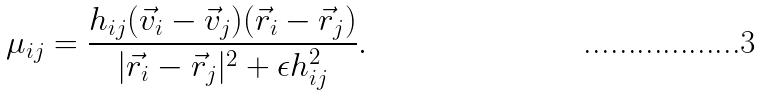Convert formula to latex. <formula><loc_0><loc_0><loc_500><loc_500>\mu _ { i j } = \frac { h _ { i j } ( { \vec { v } } _ { i } - { \vec { v } } _ { j } ) ( { \vec { r } } _ { i } - { \vec { r } } _ { j } ) } { | { \vec { r } } _ { i } - { \vec { r } } _ { j } | ^ { 2 } + \epsilon h _ { i j } ^ { 2 } } .</formula> 